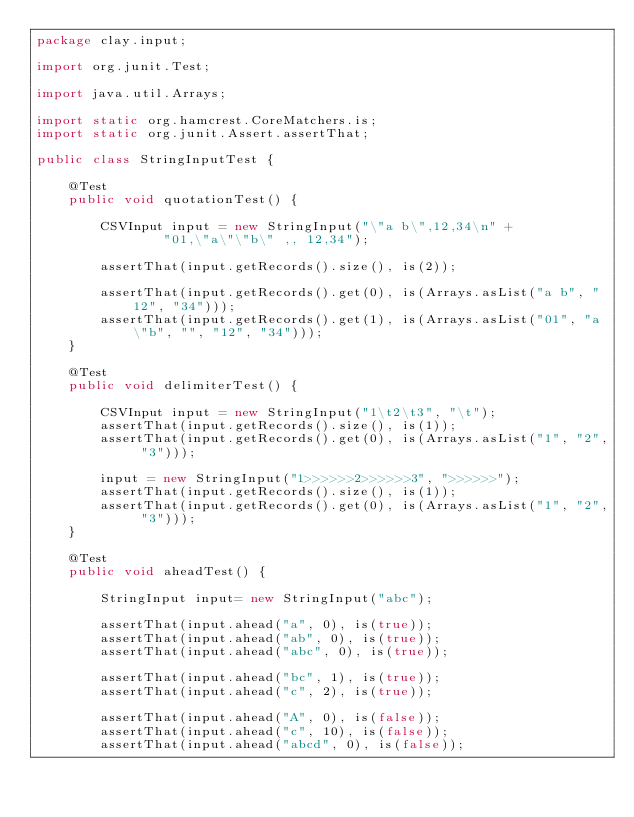Convert code to text. <code><loc_0><loc_0><loc_500><loc_500><_Java_>package clay.input;

import org.junit.Test;

import java.util.Arrays;

import static org.hamcrest.CoreMatchers.is;
import static org.junit.Assert.assertThat;

public class StringInputTest {

    @Test
    public void quotationTest() {

        CSVInput input = new StringInput("\"a b\",12,34\n" +
                "01,\"a\"\"b\" ,, 12,34");

        assertThat(input.getRecords().size(), is(2));

        assertThat(input.getRecords().get(0), is(Arrays.asList("a b", "12", "34")));
        assertThat(input.getRecords().get(1), is(Arrays.asList("01", "a\"b", "", "12", "34")));
    }

    @Test
    public void delimiterTest() {

        CSVInput input = new StringInput("1\t2\t3", "\t");
        assertThat(input.getRecords().size(), is(1));
        assertThat(input.getRecords().get(0), is(Arrays.asList("1", "2", "3")));

        input = new StringInput("1>>>>>>2>>>>>>3", ">>>>>>");
        assertThat(input.getRecords().size(), is(1));
        assertThat(input.getRecords().get(0), is(Arrays.asList("1", "2", "3")));
    }

    @Test
    public void aheadTest() {

        StringInput input= new StringInput("abc");

        assertThat(input.ahead("a", 0), is(true));
        assertThat(input.ahead("ab", 0), is(true));
        assertThat(input.ahead("abc", 0), is(true));

        assertThat(input.ahead("bc", 1), is(true));
        assertThat(input.ahead("c", 2), is(true));

        assertThat(input.ahead("A", 0), is(false));
        assertThat(input.ahead("c", 10), is(false));
        assertThat(input.ahead("abcd", 0), is(false));</code> 